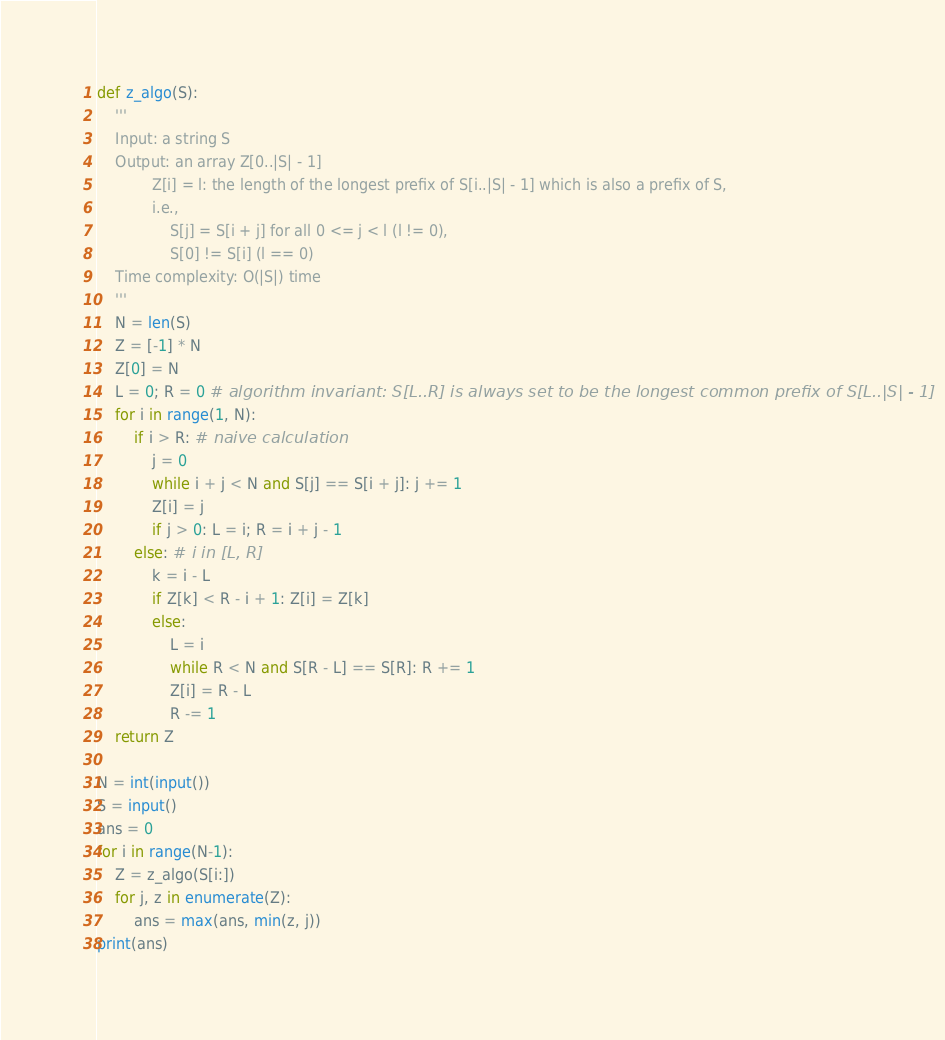Convert code to text. <code><loc_0><loc_0><loc_500><loc_500><_Python_>def z_algo(S):
    '''
    Input: a string S
    Output: an array Z[0..|S| - 1]
            Z[i] = l: the length of the longest prefix of S[i..|S| - 1] which is also a prefix of S,
            i.e.,
                S[j] = S[i + j] for all 0 <= j < l (l != 0),
                S[0] != S[i] (l == 0)
    Time complexity: O(|S|) time
    '''
    N = len(S)
    Z = [-1] * N
    Z[0] = N
    L = 0; R = 0 # algorithm invariant: S[L..R] is always set to be the longest common prefix of S[L..|S| - 1]
    for i in range(1, N):
        if i > R: # naive calculation
            j = 0
            while i + j < N and S[j] == S[i + j]: j += 1
            Z[i] = j
            if j > 0: L = i; R = i + j - 1
        else: # i in [L, R]
            k = i - L
            if Z[k] < R - i + 1: Z[i] = Z[k]
            else:
                L = i
                while R < N and S[R - L] == S[R]: R += 1
                Z[i] = R - L
                R -= 1
    return Z

N = int(input())
S = input()
ans = 0
for i in range(N-1):
    Z = z_algo(S[i:])
    for j, z in enumerate(Z):
        ans = max(ans, min(z, j))
print(ans)</code> 